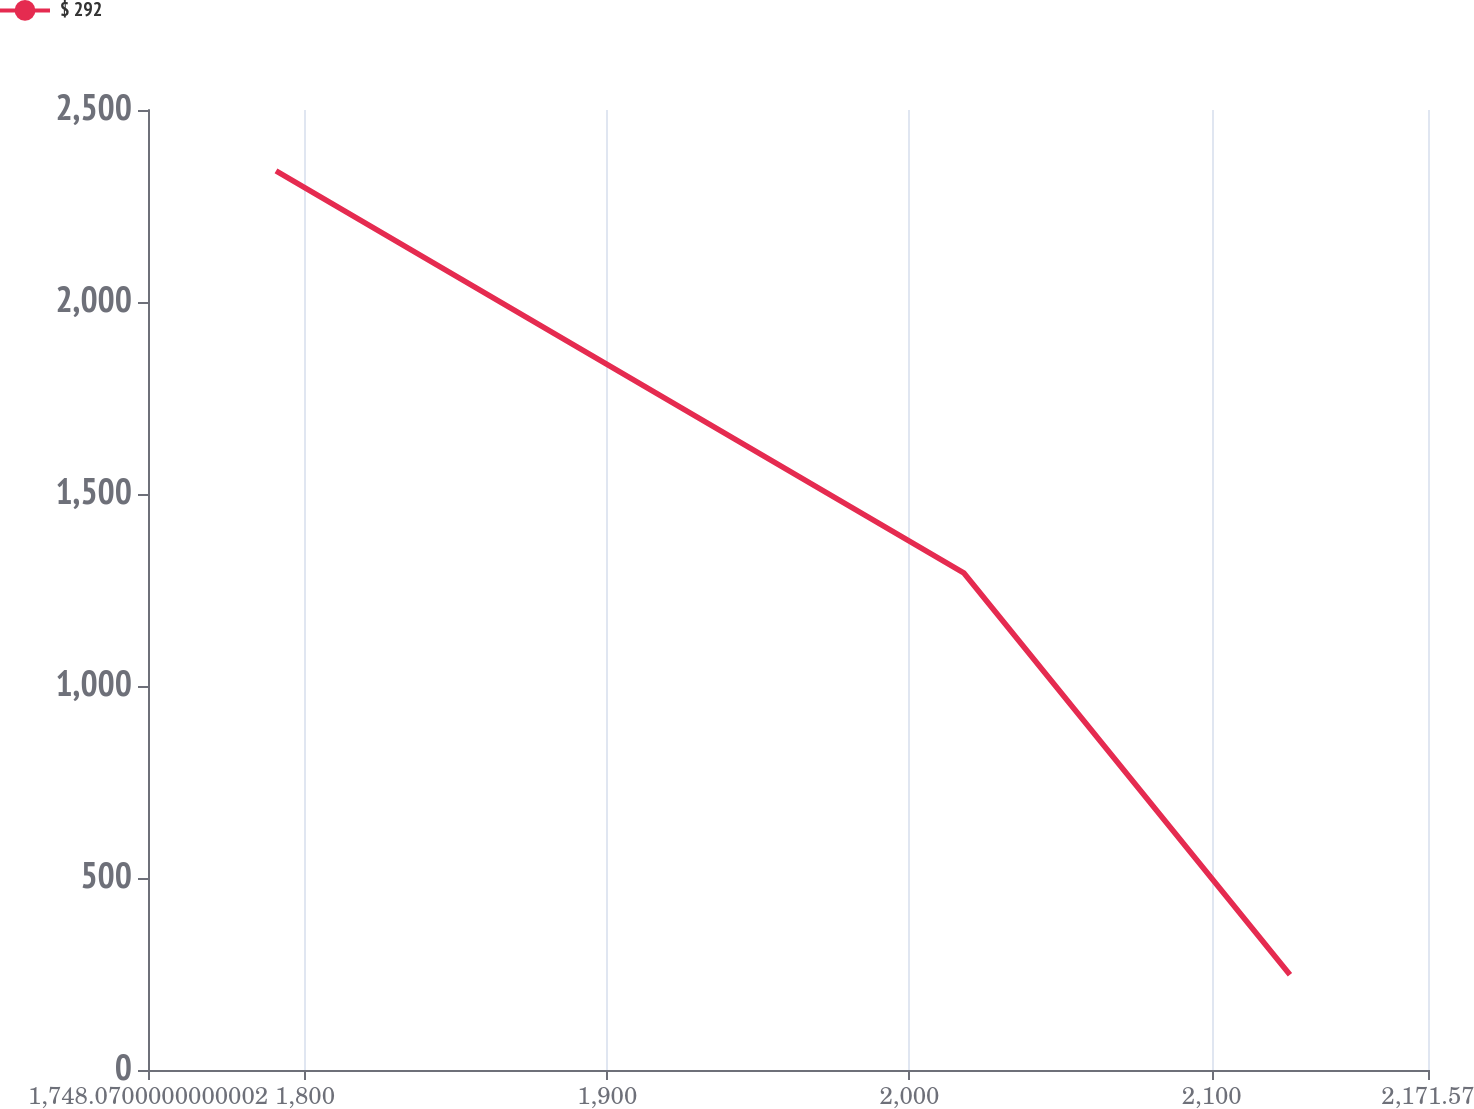Convert chart to OTSL. <chart><loc_0><loc_0><loc_500><loc_500><line_chart><ecel><fcel>$ 292<nl><fcel>1790.42<fcel>2341.4<nl><fcel>2017.94<fcel>1294.72<nl><fcel>2125.89<fcel>248.04<nl><fcel>2213.92<fcel>10714.8<nl></chart> 